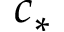<formula> <loc_0><loc_0><loc_500><loc_500>c _ { * }</formula> 